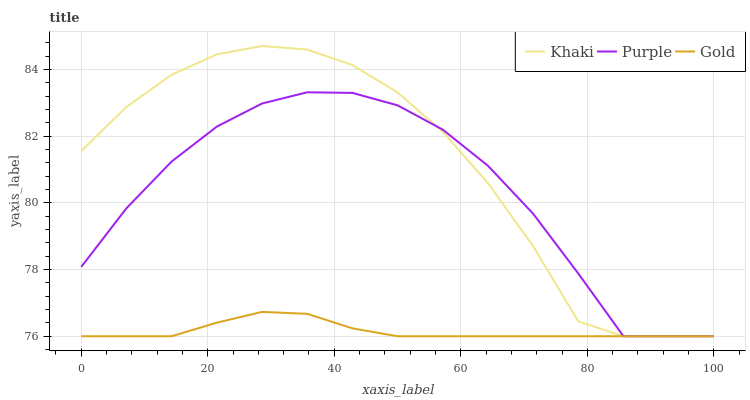Does Gold have the minimum area under the curve?
Answer yes or no. Yes. Does Khaki have the maximum area under the curve?
Answer yes or no. Yes. Does Khaki have the minimum area under the curve?
Answer yes or no. No. Does Gold have the maximum area under the curve?
Answer yes or no. No. Is Gold the smoothest?
Answer yes or no. Yes. Is Khaki the roughest?
Answer yes or no. Yes. Is Khaki the smoothest?
Answer yes or no. No. Is Gold the roughest?
Answer yes or no. No. Does Purple have the lowest value?
Answer yes or no. Yes. Does Khaki have the highest value?
Answer yes or no. Yes. Does Gold have the highest value?
Answer yes or no. No. Does Gold intersect Khaki?
Answer yes or no. Yes. Is Gold less than Khaki?
Answer yes or no. No. Is Gold greater than Khaki?
Answer yes or no. No. 